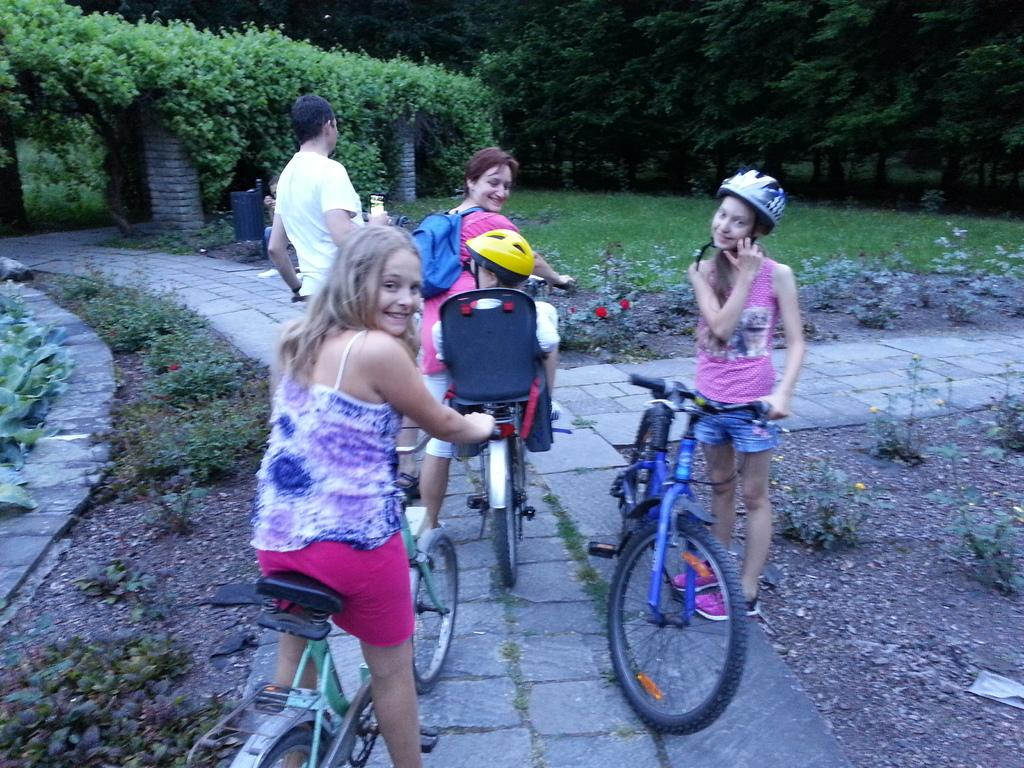Who is present in the picture? There are kids in the picture. What are the kids doing in the picture? The kids are sitting on bicycles. Where are the kids located in the picture? The kids are on a path. What can be seen on either side of the path? There is a garden on either side of the path. What type of vegetation is present in the garden? There are plants in the garden. How many women are present in the picture? There is no mention of women in the provided facts, so we cannot determine the number of women present in the image. 